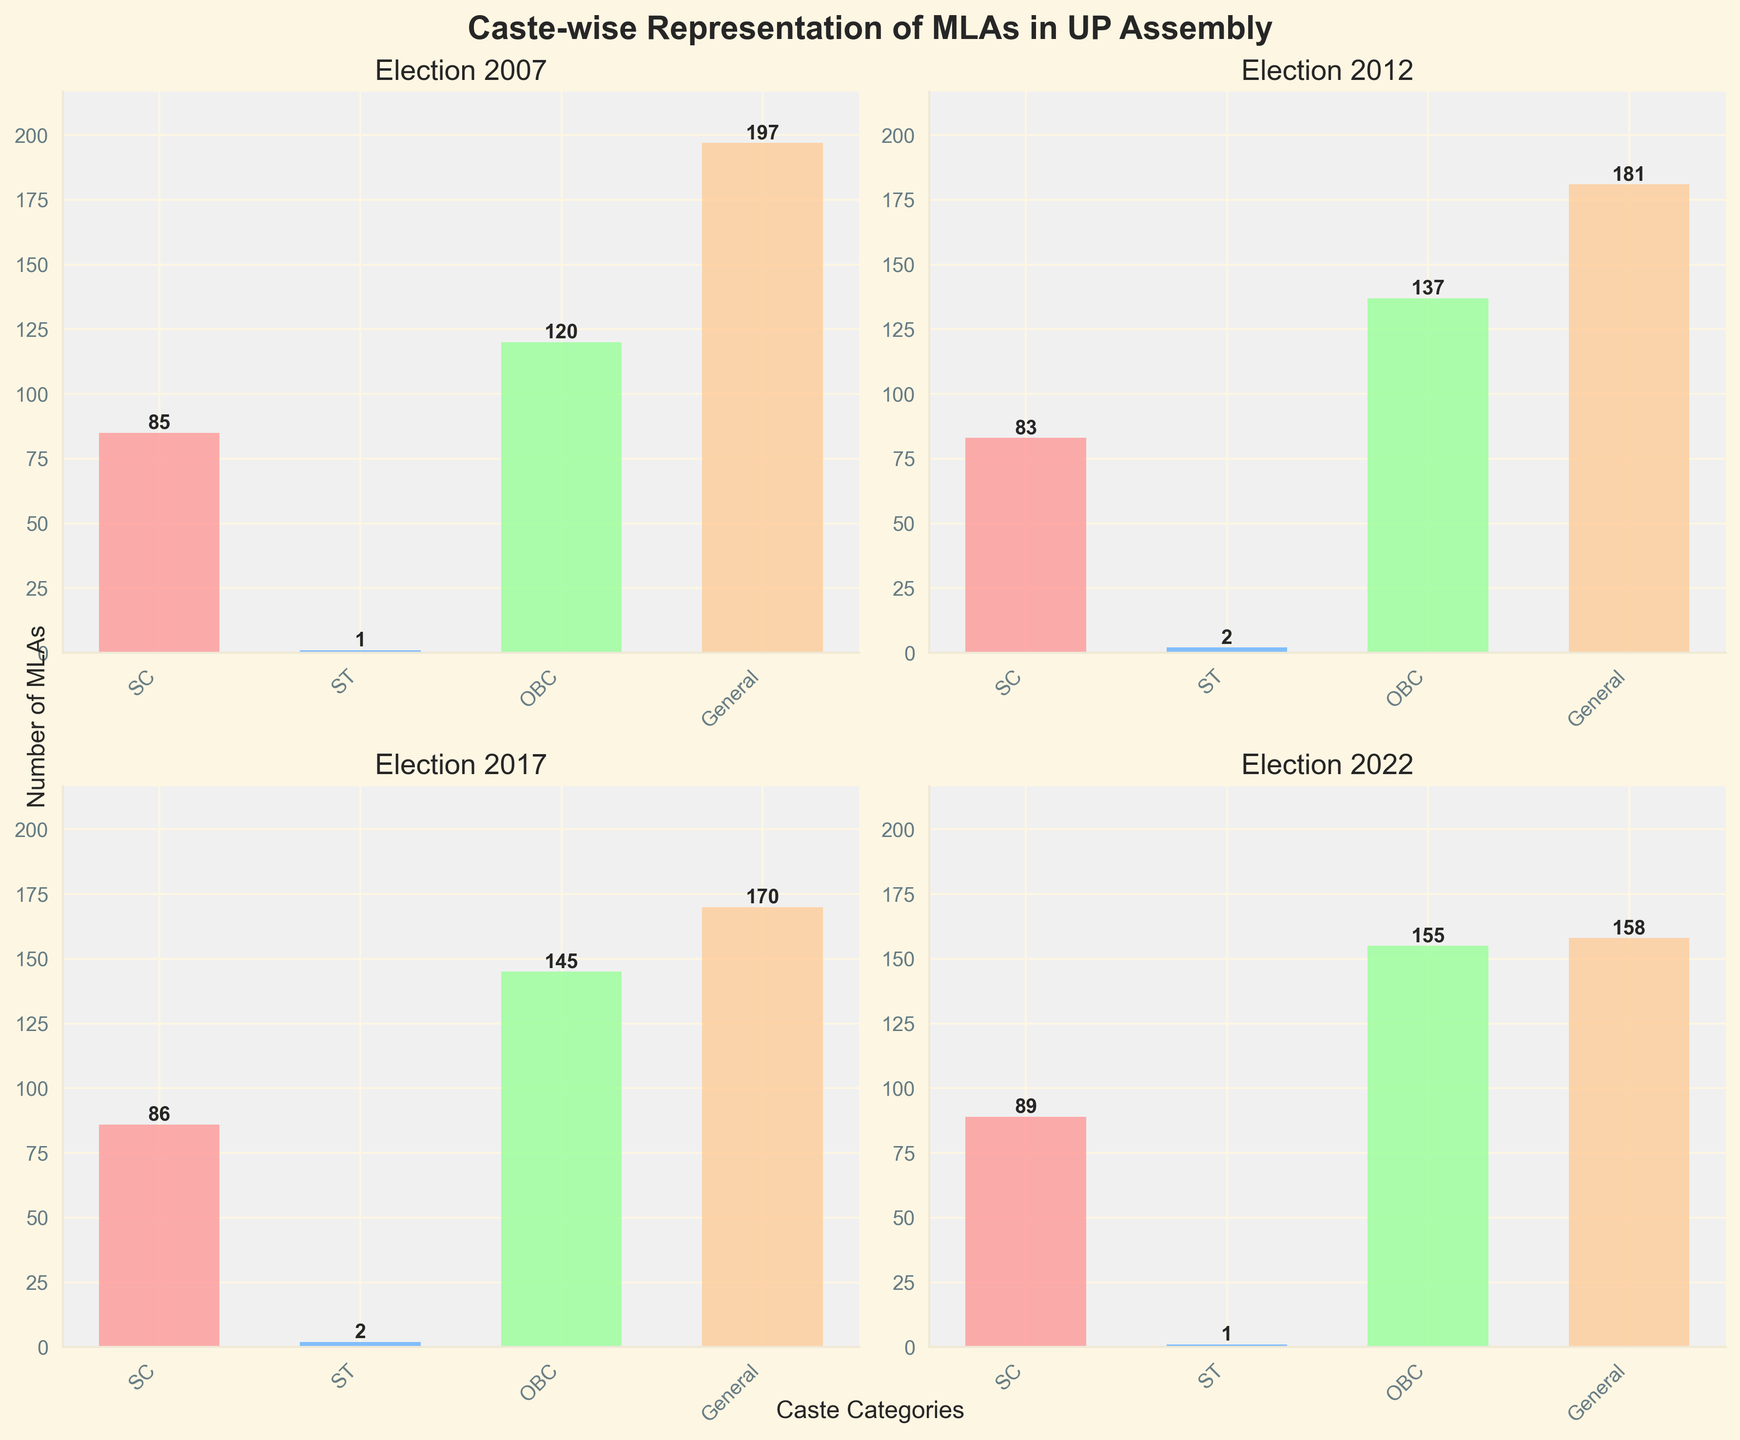Which caste group saw the largest increase in MLAs from 2007 to 2022? The number of SC MLAs increased from 85 to 89 (an increase of 4), ST from 1 to 1 (no increase), OBC from 120 to 155 (an increase of 35), and General from 197 to 158 (a decrease of 39). Therefore, OBC saw the largest increase.
Answer: OBC How many more General caste MLAs were there compared to OBC MLAs in 2007? In 2007, General MLAs were 197 and OBC MLAs were 120. The difference is 197 - 120 = 77.
Answer: 77 What was the total number of MLAs from SC and ST categories in 2017? In 2017, there were 86 SC MLAs and 2 ST MLAs. Adding them gives 86 + 2 = 88.
Answer: 88 Which caste group had the smallest representation in all four elections? In all four elections (2007, 2012, 2017, 2022), the ST category consistently had the smallest number of MLAs (1 or 2).
Answer: ST What is the trend in the representation of OBC MLAs from 2007 to 2022? The number of OBC MLAs in each election were 120 (2007), 137 (2012), 145 (2017), 155 (2022). This shows a consistently increasing trend.
Answer: Increasing Did the number of General caste MLAs increase or decrease over the four elections? From 2007 to 2022, the number of General caste MLAs decreased from 197 to 181 to 170 to 158.
Answer: Decrease By how many MLAs did the combined count of SC and OBC representatives change from 2007 to 2022? In 2007, SC and OBC combined were 85 + 120 = 205. In 2022, they were 89 + 155 = 244. The change is 244 - 205 = 39.
Answer: 39 Which election year had the maximum total count of SC and General MLAs combined? Calculating for each year: 2007: 85 (SC) + 197 (General) = 282, 2012: 83 + 181 = 264, 2017: 86 + 170 = 256, 2022: 89 + 158 = 247. The maximum is in 2007 with 282 MLAs combined.
Answer: 2007 How did the representation of ST MLAs change in 2012 compared to the previous and subsequent years? In 2012, the number of ST MLAs was 2, which was an increase from 1 in 2007, and remained 2 in 2017, then returned to 1 in 2022.
Answer: Increased in 2012 then remained same and finally decreased in 2022 